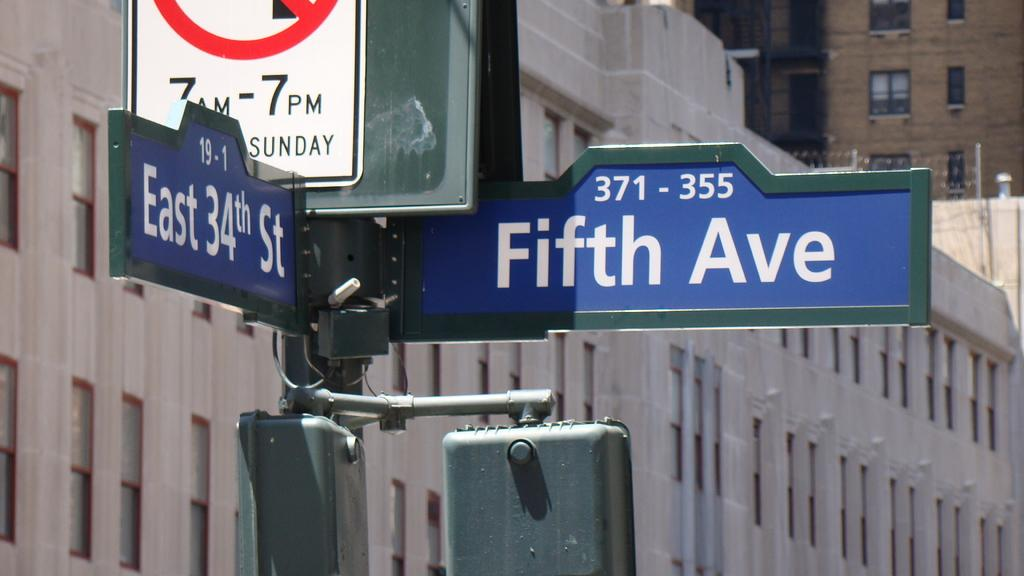<image>
Present a compact description of the photo's key features. A blue street sign with Fifth Ave written on it. 